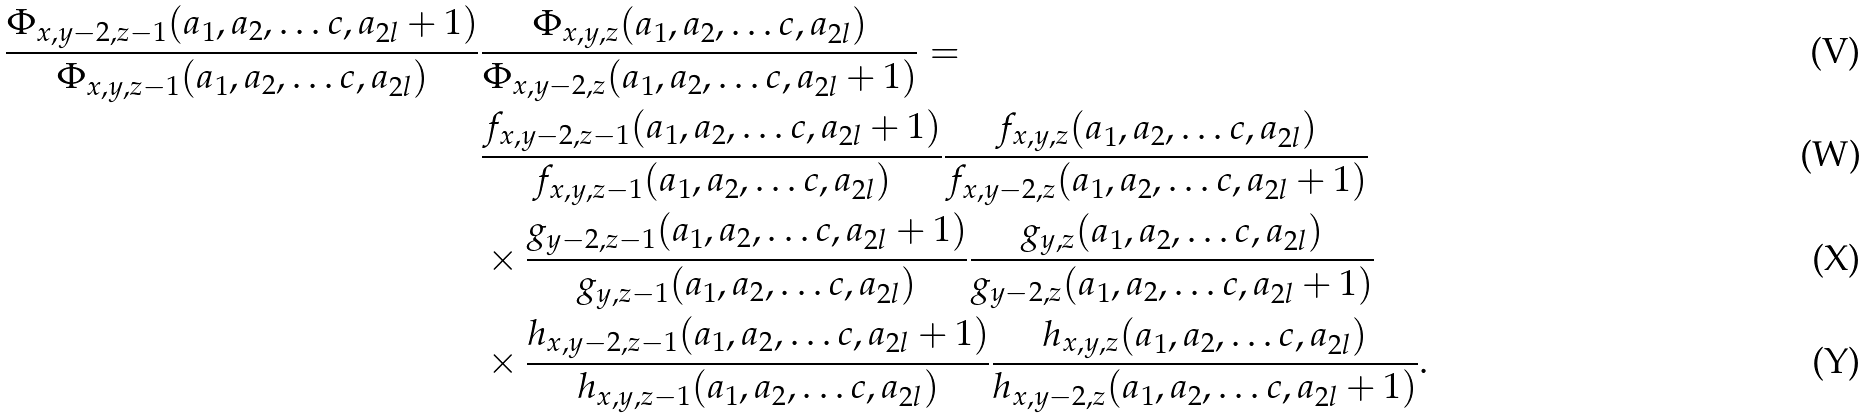Convert formula to latex. <formula><loc_0><loc_0><loc_500><loc_500>\frac { \Phi _ { x , y - 2 , z - 1 } ( a _ { 1 } , a _ { 2 } , \dots c , a _ { 2 l } + 1 ) } { \Phi _ { x , y , z - 1 } ( a _ { 1 } , a _ { 2 } , \dots c , a _ { 2 l } ) } & \frac { \Phi _ { x , y , z } ( a _ { 1 } , a _ { 2 } , \dots c , a _ { 2 l } ) } { \Phi _ { x , y - 2 , z } ( a _ { 1 } , a _ { 2 } , \dots c , a _ { 2 l } + 1 ) } = \\ & \frac { f _ { x , y - 2 , z - 1 } ( a _ { 1 } , a _ { 2 } , \dots c , a _ { 2 l } + 1 ) } { f _ { x , y , z - 1 } ( a _ { 1 } , a _ { 2 } , \dots c , a _ { 2 l } ) } \frac { f _ { x , y , z } ( a _ { 1 } , a _ { 2 } , \dots c , a _ { 2 l } ) } { f _ { x , y - 2 , z } ( a _ { 1 } , a _ { 2 } , \dots c , a _ { 2 l } + 1 ) } \\ & \times \frac { g _ { y - 2 , z - 1 } ( a _ { 1 } , a _ { 2 } , \dots c , a _ { 2 l } + 1 ) } { g _ { y , z - 1 } ( a _ { 1 } , a _ { 2 } , \dots c , a _ { 2 l } ) } \frac { g _ { y , z } ( a _ { 1 } , a _ { 2 } , \dots c , a _ { 2 l } ) } { g _ { y - 2 , z } ( a _ { 1 } , a _ { 2 } , \dots c , a _ { 2 l } + 1 ) } \\ & \times \frac { h _ { x , y - 2 , z - 1 } ( a _ { 1 } , a _ { 2 } , \dots c , a _ { 2 l } + 1 ) } { h _ { x , y , z - 1 } ( a _ { 1 } , a _ { 2 } , \dots c , a _ { 2 l } ) } \frac { h _ { x , y , z } ( a _ { 1 } , a _ { 2 } , \dots c , a _ { 2 l } ) } { h _ { x , y - 2 , z } ( a _ { 1 } , a _ { 2 } , \dots c , a _ { 2 l } + 1 ) } .</formula> 